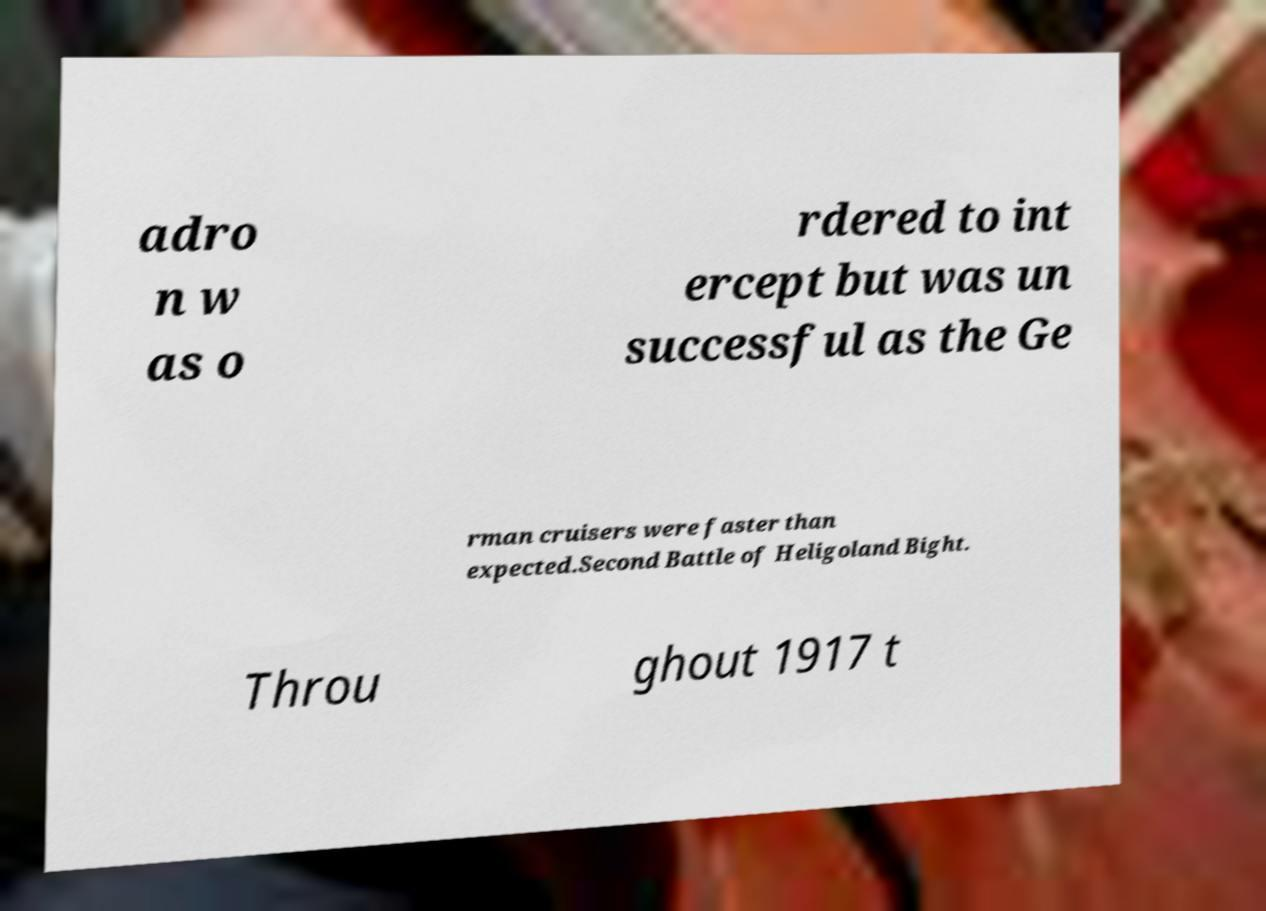Please identify and transcribe the text found in this image. adro n w as o rdered to int ercept but was un successful as the Ge rman cruisers were faster than expected.Second Battle of Heligoland Bight. Throu ghout 1917 t 